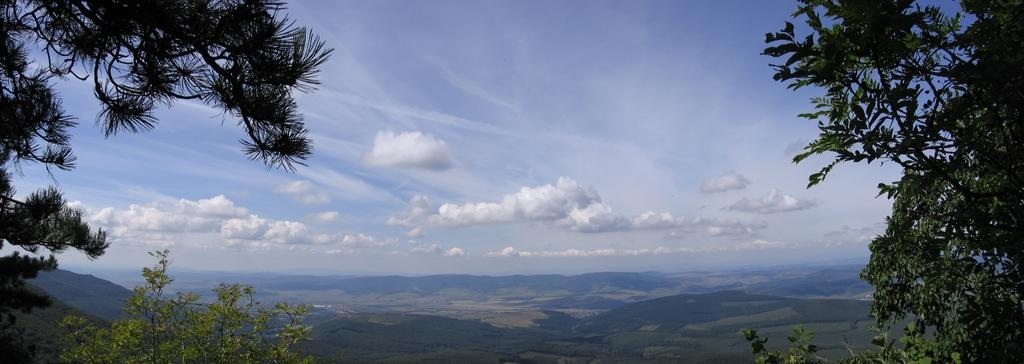What type of vegetation can be seen at the bottom of the image? There is greenery at the bottom of the image. Can you describe the greenery on the right side of the image? There is greenery on the right side of the image. What is visible on the left side of the image? There is greenery on the left side of the image. What is visible at the top of the image? The sky is visible at the top of the image. What type of button can be seen on the spoon in the image? There is no button or spoon present in the image; it only features greenery and the sky. What type of humor can be found in the image? There is no humor depicted in the image; it is a simple representation of greenery and the sky. 